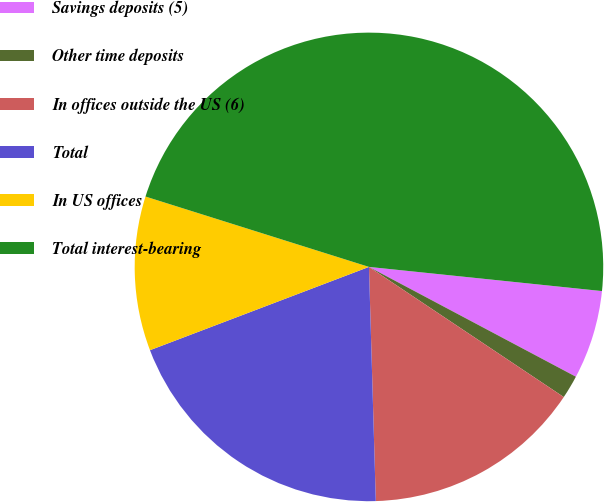Convert chart to OTSL. <chart><loc_0><loc_0><loc_500><loc_500><pie_chart><fcel>Savings deposits (5)<fcel>Other time deposits<fcel>In offices outside the US (6)<fcel>Total<fcel>In US offices<fcel>Total interest-bearing<nl><fcel>6.12%<fcel>1.61%<fcel>15.16%<fcel>19.68%<fcel>10.64%<fcel>46.79%<nl></chart> 